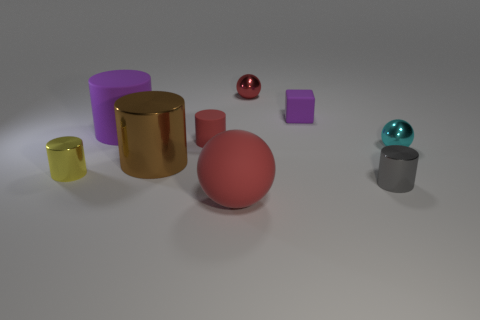Subtract all blue cubes. How many red spheres are left? 2 Subtract all red spheres. How many spheres are left? 1 Add 1 yellow metallic things. How many objects exist? 10 Subtract all yellow cylinders. How many cylinders are left? 4 Subtract all brown cylinders. Subtract all green spheres. How many cylinders are left? 4 Subtract all blocks. How many objects are left? 8 Add 1 small red objects. How many small red objects exist? 3 Subtract 0 green cubes. How many objects are left? 9 Subtract all yellow metallic cylinders. Subtract all tiny matte cubes. How many objects are left? 7 Add 9 big purple rubber objects. How many big purple rubber objects are left? 10 